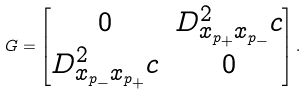<formula> <loc_0><loc_0><loc_500><loc_500>G = \begin{bmatrix} 0 & D ^ { 2 } _ { x _ { p _ { + } } x _ { p _ { - } } } c \\ D ^ { 2 } _ { x _ { p _ { - } } x _ { p _ { + } } } c & 0 \end{bmatrix} .</formula> 